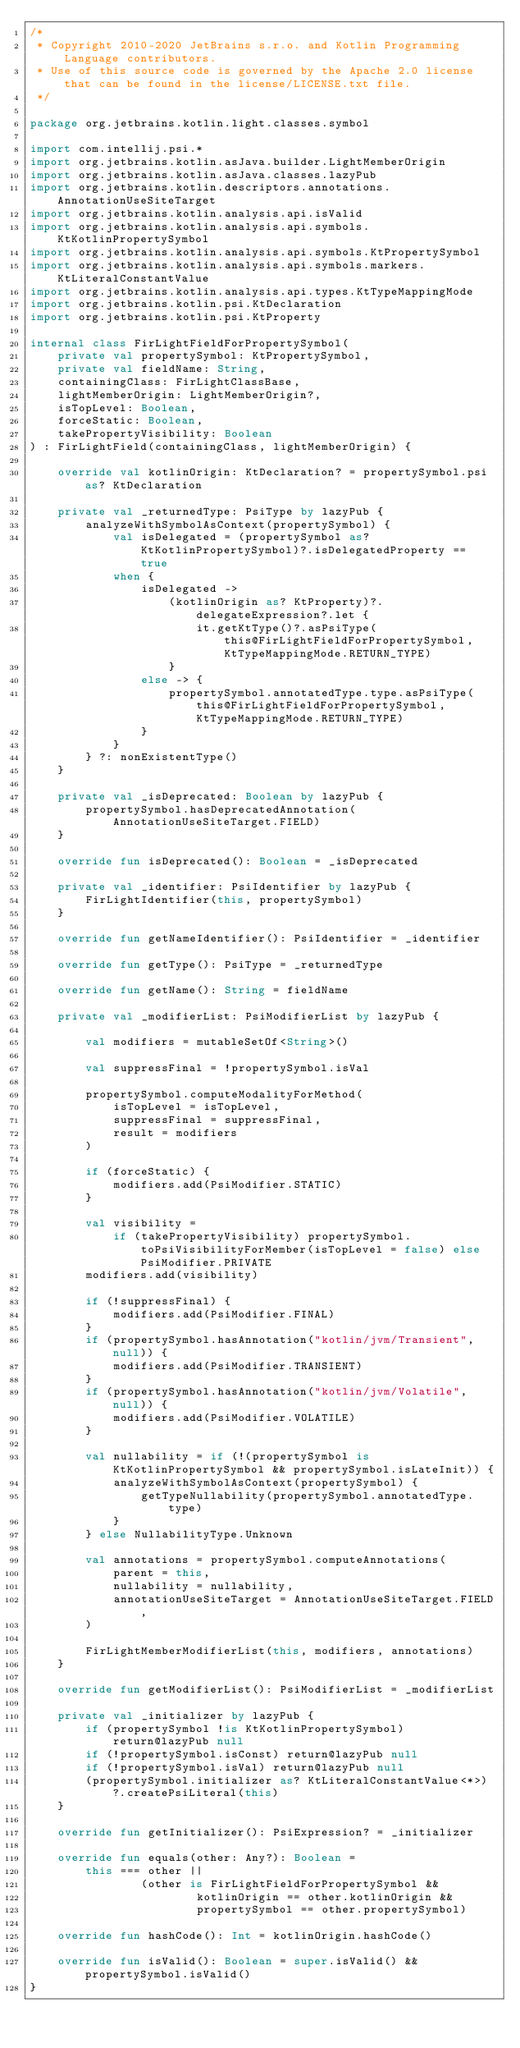Convert code to text. <code><loc_0><loc_0><loc_500><loc_500><_Kotlin_>/*
 * Copyright 2010-2020 JetBrains s.r.o. and Kotlin Programming Language contributors.
 * Use of this source code is governed by the Apache 2.0 license that can be found in the license/LICENSE.txt file.
 */

package org.jetbrains.kotlin.light.classes.symbol

import com.intellij.psi.*
import org.jetbrains.kotlin.asJava.builder.LightMemberOrigin
import org.jetbrains.kotlin.asJava.classes.lazyPub
import org.jetbrains.kotlin.descriptors.annotations.AnnotationUseSiteTarget
import org.jetbrains.kotlin.analysis.api.isValid
import org.jetbrains.kotlin.analysis.api.symbols.KtKotlinPropertySymbol
import org.jetbrains.kotlin.analysis.api.symbols.KtPropertySymbol
import org.jetbrains.kotlin.analysis.api.symbols.markers.KtLiteralConstantValue
import org.jetbrains.kotlin.analysis.api.types.KtTypeMappingMode
import org.jetbrains.kotlin.psi.KtDeclaration
import org.jetbrains.kotlin.psi.KtProperty

internal class FirLightFieldForPropertySymbol(
    private val propertySymbol: KtPropertySymbol,
    private val fieldName: String,
    containingClass: FirLightClassBase,
    lightMemberOrigin: LightMemberOrigin?,
    isTopLevel: Boolean,
    forceStatic: Boolean,
    takePropertyVisibility: Boolean
) : FirLightField(containingClass, lightMemberOrigin) {

    override val kotlinOrigin: KtDeclaration? = propertySymbol.psi as? KtDeclaration

    private val _returnedType: PsiType by lazyPub {
        analyzeWithSymbolAsContext(propertySymbol) {
            val isDelegated = (propertySymbol as? KtKotlinPropertySymbol)?.isDelegatedProperty == true
            when {
                isDelegated ->
                    (kotlinOrigin as? KtProperty)?.delegateExpression?.let {
                        it.getKtType()?.asPsiType(this@FirLightFieldForPropertySymbol, KtTypeMappingMode.RETURN_TYPE)
                    }
                else -> {
                    propertySymbol.annotatedType.type.asPsiType(this@FirLightFieldForPropertySymbol, KtTypeMappingMode.RETURN_TYPE)
                }
            }
        } ?: nonExistentType()
    }

    private val _isDeprecated: Boolean by lazyPub {
        propertySymbol.hasDeprecatedAnnotation(AnnotationUseSiteTarget.FIELD)
    }

    override fun isDeprecated(): Boolean = _isDeprecated

    private val _identifier: PsiIdentifier by lazyPub {
        FirLightIdentifier(this, propertySymbol)
    }

    override fun getNameIdentifier(): PsiIdentifier = _identifier

    override fun getType(): PsiType = _returnedType

    override fun getName(): String = fieldName

    private val _modifierList: PsiModifierList by lazyPub {

        val modifiers = mutableSetOf<String>()

        val suppressFinal = !propertySymbol.isVal

        propertySymbol.computeModalityForMethod(
            isTopLevel = isTopLevel,
            suppressFinal = suppressFinal,
            result = modifiers
        )

        if (forceStatic) {
            modifiers.add(PsiModifier.STATIC)
        }

        val visibility =
            if (takePropertyVisibility) propertySymbol.toPsiVisibilityForMember(isTopLevel = false) else PsiModifier.PRIVATE
        modifiers.add(visibility)

        if (!suppressFinal) {
            modifiers.add(PsiModifier.FINAL)
        }
        if (propertySymbol.hasAnnotation("kotlin/jvm/Transient", null)) {
            modifiers.add(PsiModifier.TRANSIENT)
        }
        if (propertySymbol.hasAnnotation("kotlin/jvm/Volatile", null)) {
            modifiers.add(PsiModifier.VOLATILE)
        }

        val nullability = if (!(propertySymbol is KtKotlinPropertySymbol && propertySymbol.isLateInit)) {
            analyzeWithSymbolAsContext(propertySymbol) {
                getTypeNullability(propertySymbol.annotatedType.type)
            }
        } else NullabilityType.Unknown

        val annotations = propertySymbol.computeAnnotations(
            parent = this,
            nullability = nullability,
            annotationUseSiteTarget = AnnotationUseSiteTarget.FIELD,
        )

        FirLightMemberModifierList(this, modifiers, annotations)
    }

    override fun getModifierList(): PsiModifierList = _modifierList

    private val _initializer by lazyPub {
        if (propertySymbol !is KtKotlinPropertySymbol) return@lazyPub null
        if (!propertySymbol.isConst) return@lazyPub null
        if (!propertySymbol.isVal) return@lazyPub null
        (propertySymbol.initializer as? KtLiteralConstantValue<*>)?.createPsiLiteral(this)
    }

    override fun getInitializer(): PsiExpression? = _initializer

    override fun equals(other: Any?): Boolean =
        this === other ||
                (other is FirLightFieldForPropertySymbol &&
                        kotlinOrigin == other.kotlinOrigin &&
                        propertySymbol == other.propertySymbol)

    override fun hashCode(): Int = kotlinOrigin.hashCode()

    override fun isValid(): Boolean = super.isValid() && propertySymbol.isValid()
}
</code> 